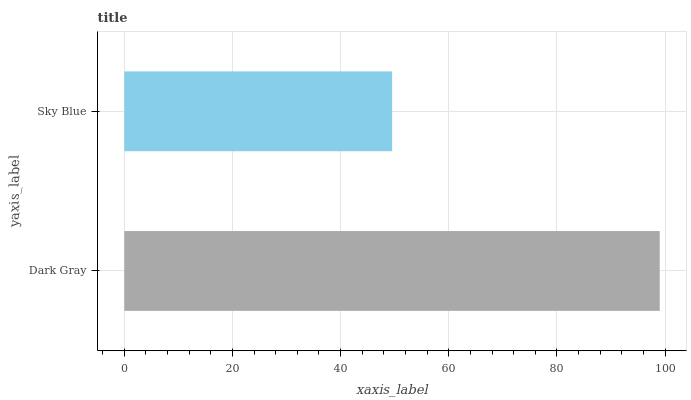Is Sky Blue the minimum?
Answer yes or no. Yes. Is Dark Gray the maximum?
Answer yes or no. Yes. Is Sky Blue the maximum?
Answer yes or no. No. Is Dark Gray greater than Sky Blue?
Answer yes or no. Yes. Is Sky Blue less than Dark Gray?
Answer yes or no. Yes. Is Sky Blue greater than Dark Gray?
Answer yes or no. No. Is Dark Gray less than Sky Blue?
Answer yes or no. No. Is Dark Gray the high median?
Answer yes or no. Yes. Is Sky Blue the low median?
Answer yes or no. Yes. Is Sky Blue the high median?
Answer yes or no. No. Is Dark Gray the low median?
Answer yes or no. No. 